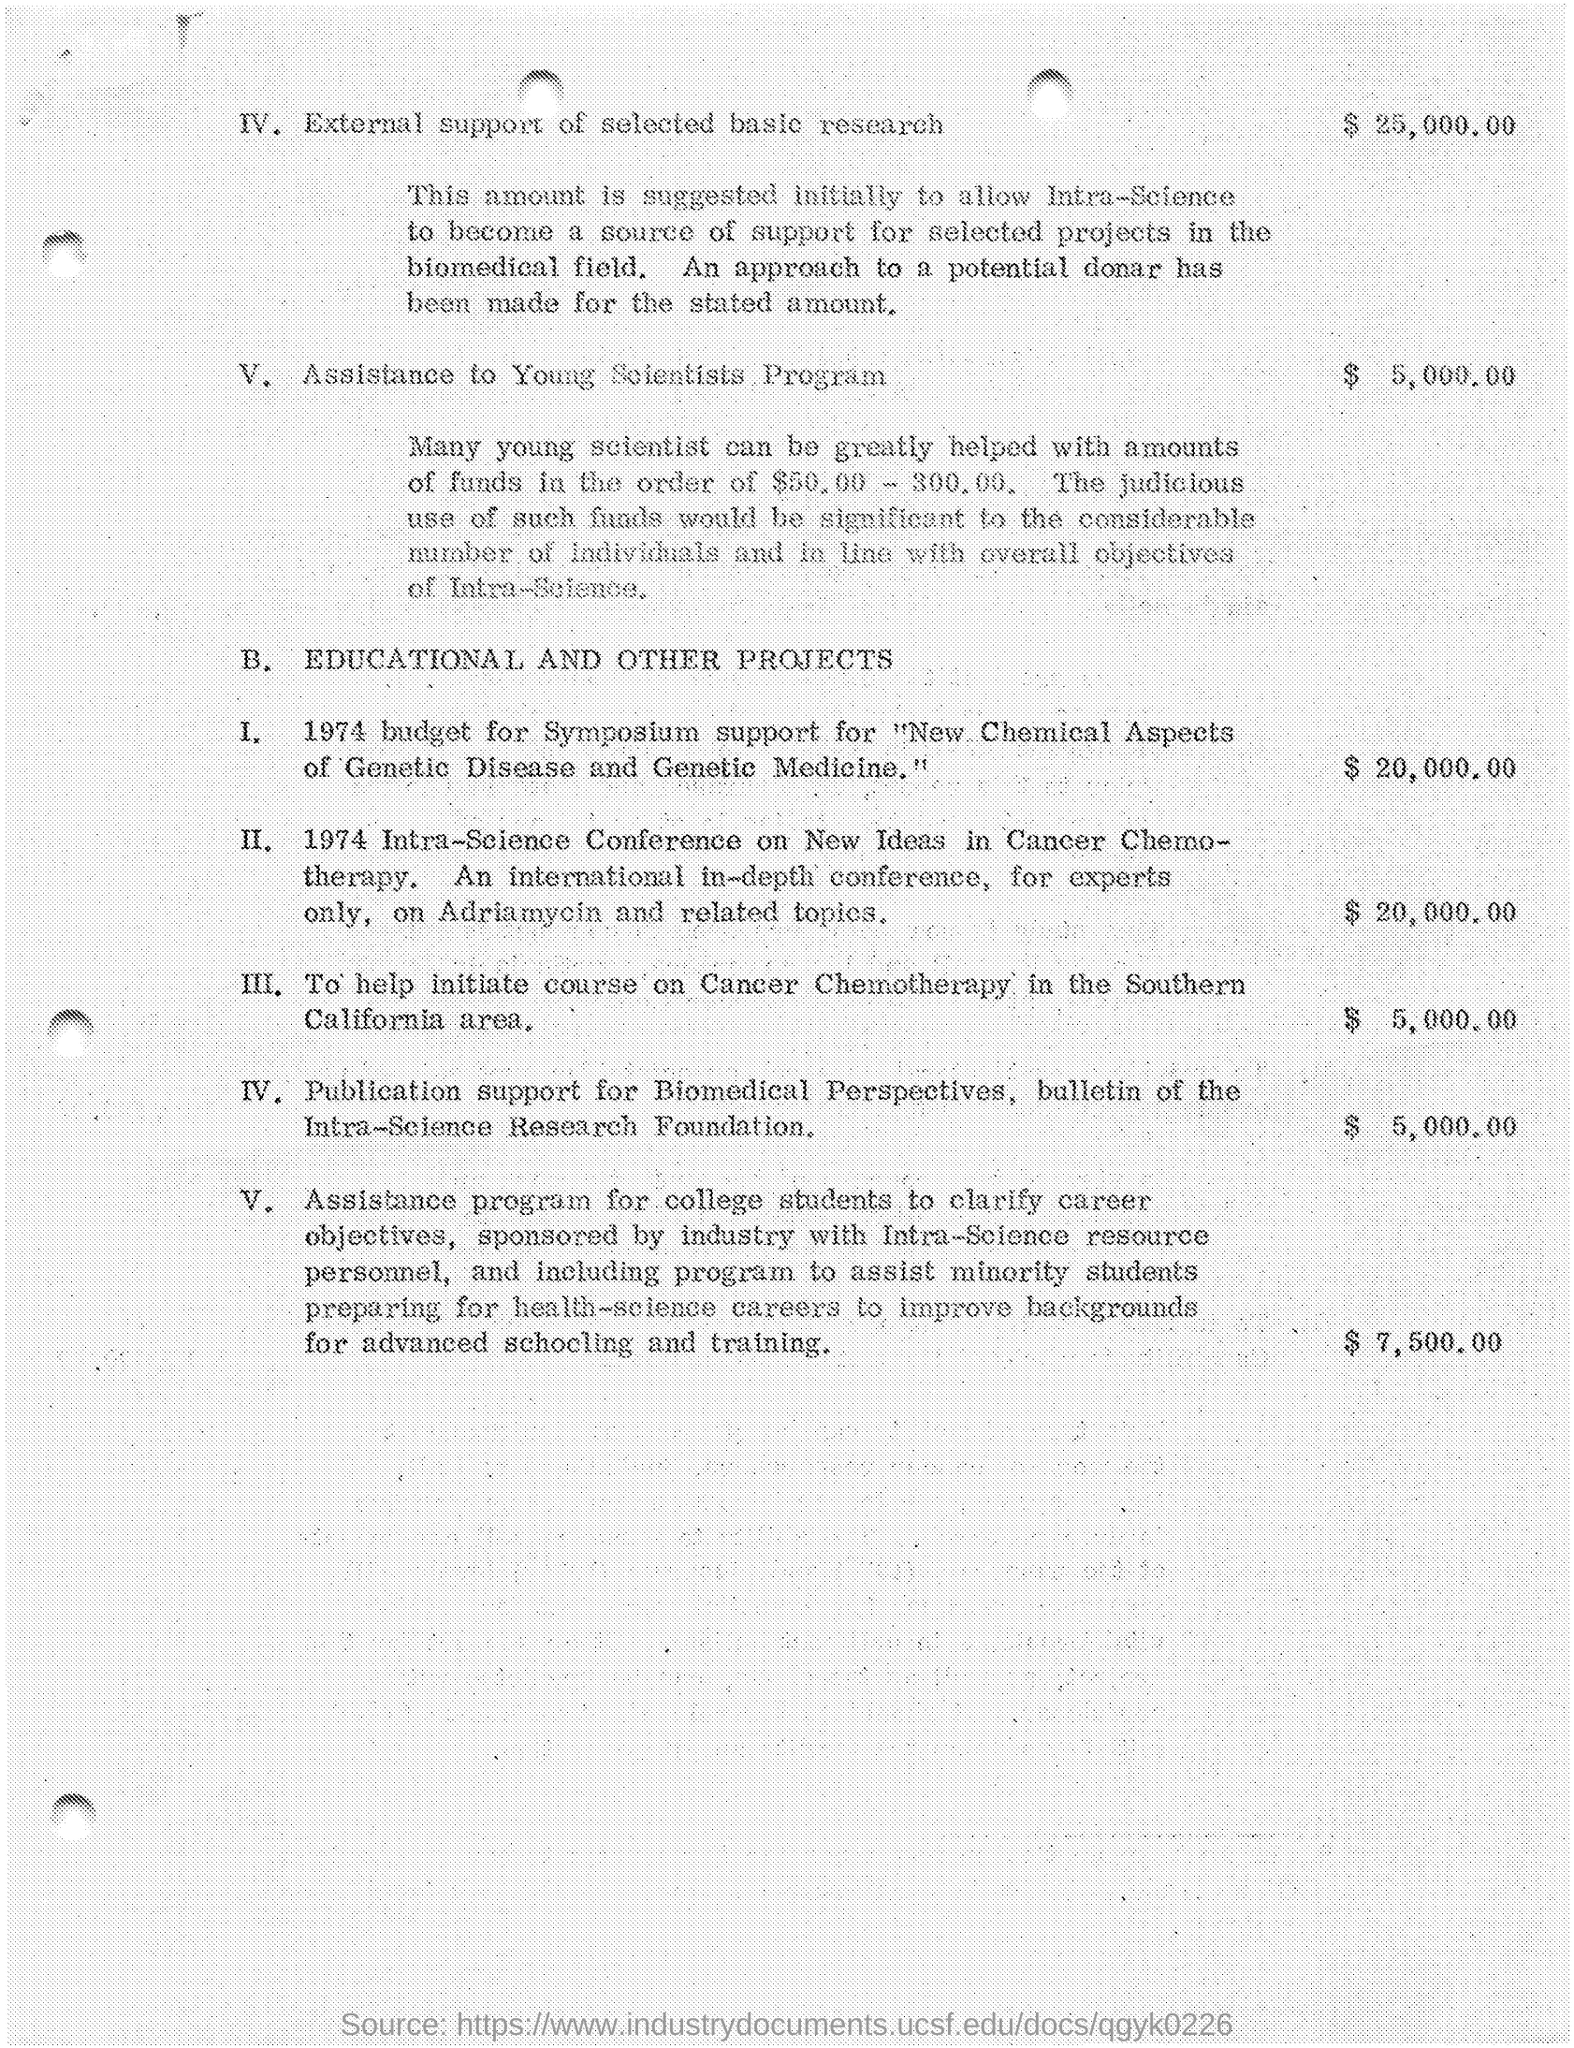What is the amount mentioned for external support of selected basic research ?
Ensure brevity in your answer.  $ 25,000.00. What is the amount given for assistance to young scientists program ?
Ensure brevity in your answer.  $ 5,000.00. What is the amount given for 1974 budget for symposium support ?
Provide a succinct answer. $ 20,000.00. What is the amount given for 1974 intra-science conference on new ideas in cancer chemotherapy ?
Make the answer very short. 20,000.00. What is the amount given for help initiate course on cancer chemotherapy in the southern california area ?
Give a very brief answer. 5,000.00. What is the amount given for publication support for biomedical perspectives, bulletin of the intra-science research foundation ?
Give a very brief answer. $ 5,000.00. 